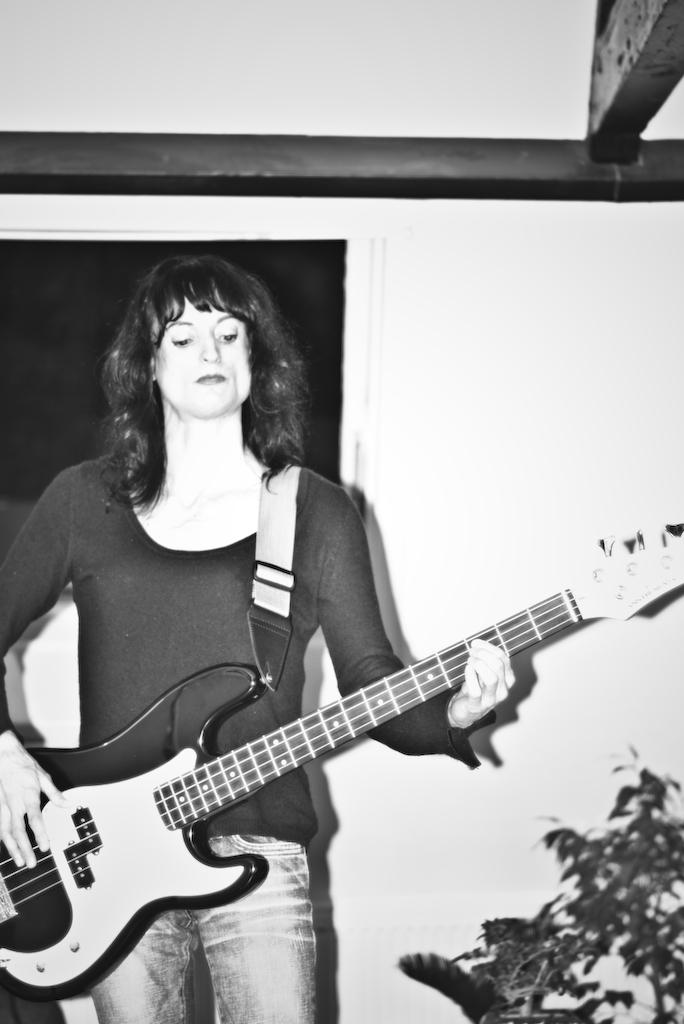Who is present in the image? There is a woman in the image. What is the woman doing in the image? The woman is standing and holding a guitar. What can be seen in the background of the image? There is a board, a plant, and a light in the background of the image. What type of paste is being used to design the guitar in the image? There is no paste or design process visible in the image; the woman is simply holding a guitar. 